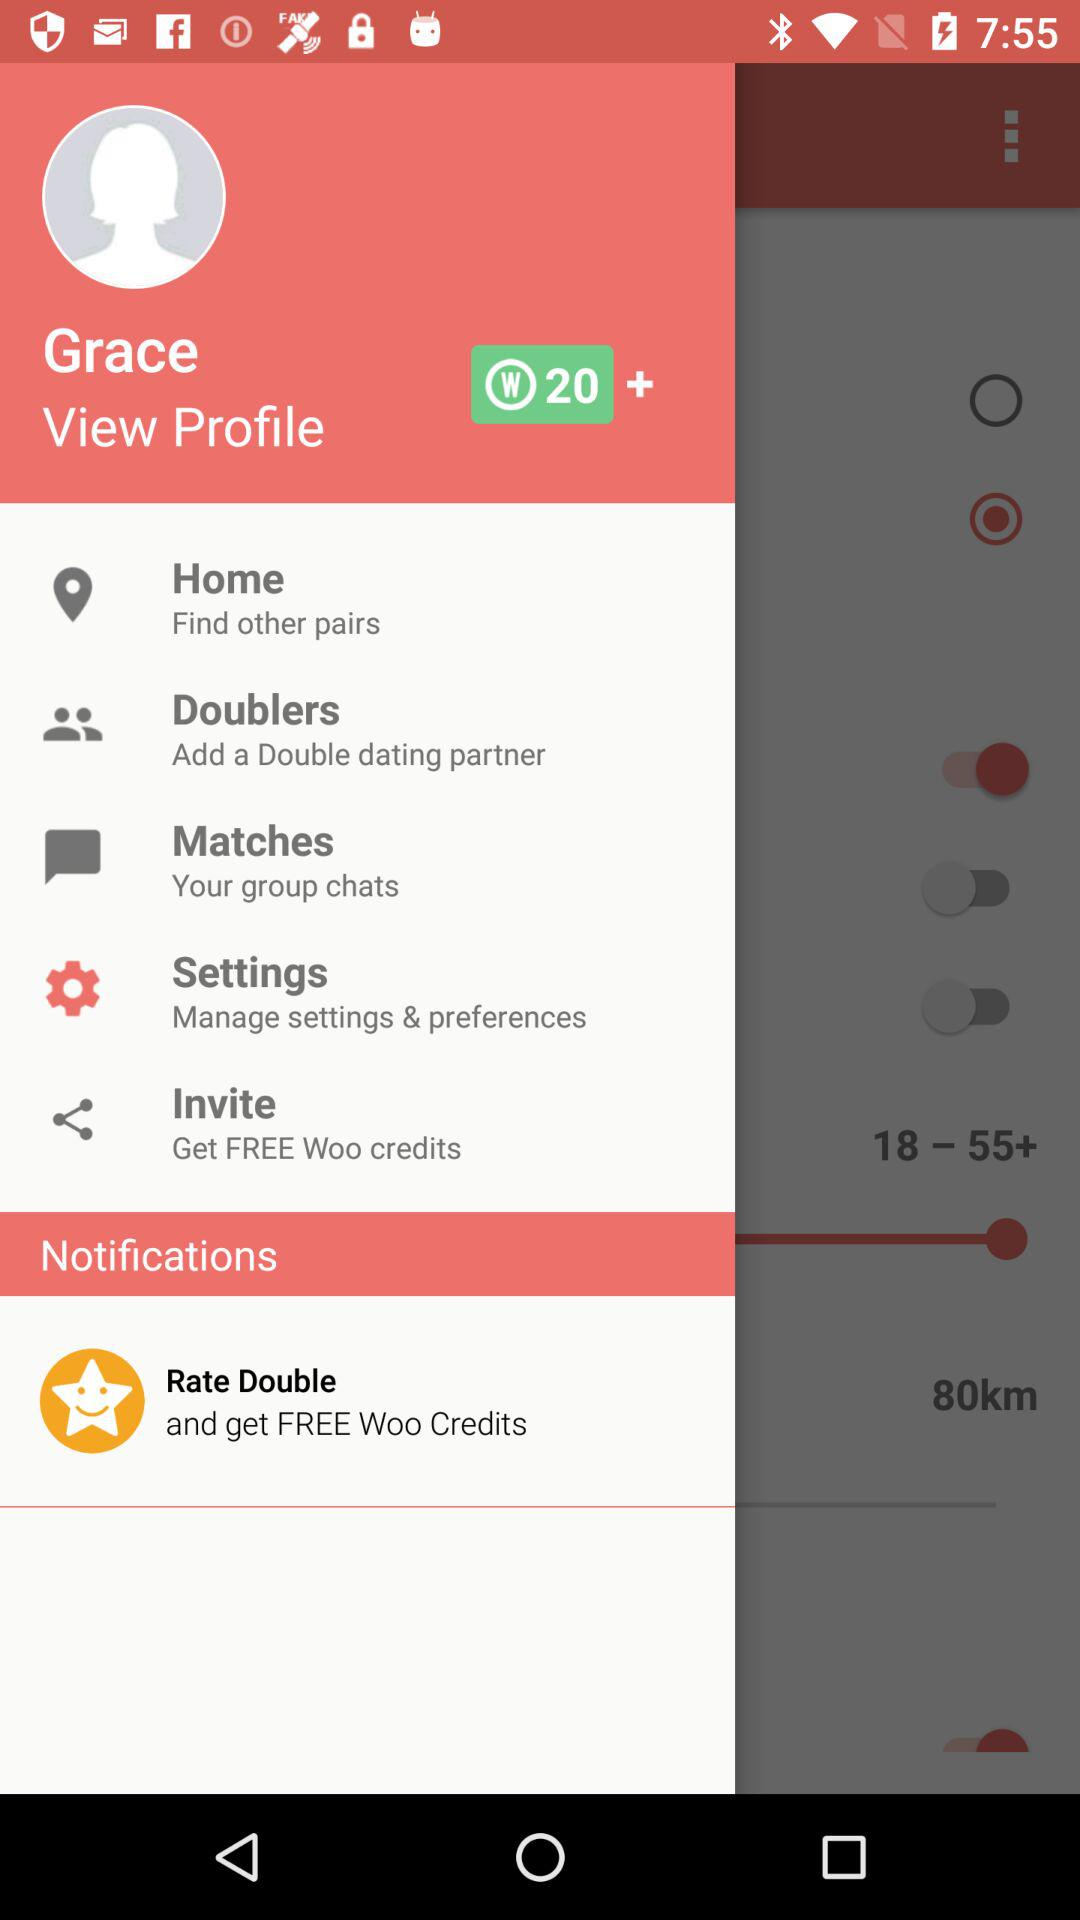How many Woo credit points does the user have? The user has 20 Woo credit points. 